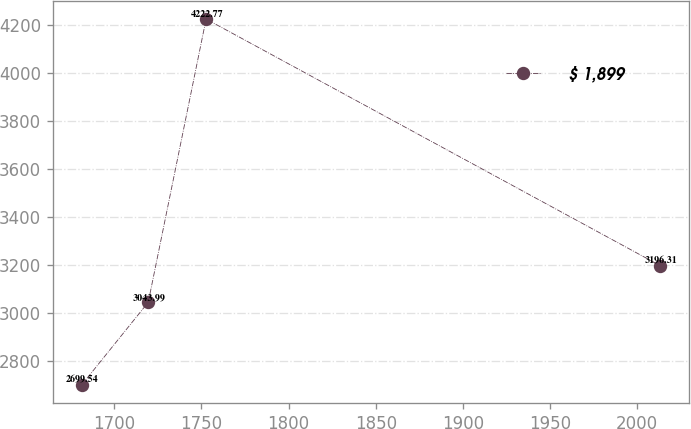<chart> <loc_0><loc_0><loc_500><loc_500><line_chart><ecel><fcel>$ 1,899<nl><fcel>1681.23<fcel>2699.54<nl><fcel>1719.49<fcel>3043.99<nl><fcel>1752.69<fcel>4222.77<nl><fcel>2013.2<fcel>3196.31<nl></chart> 